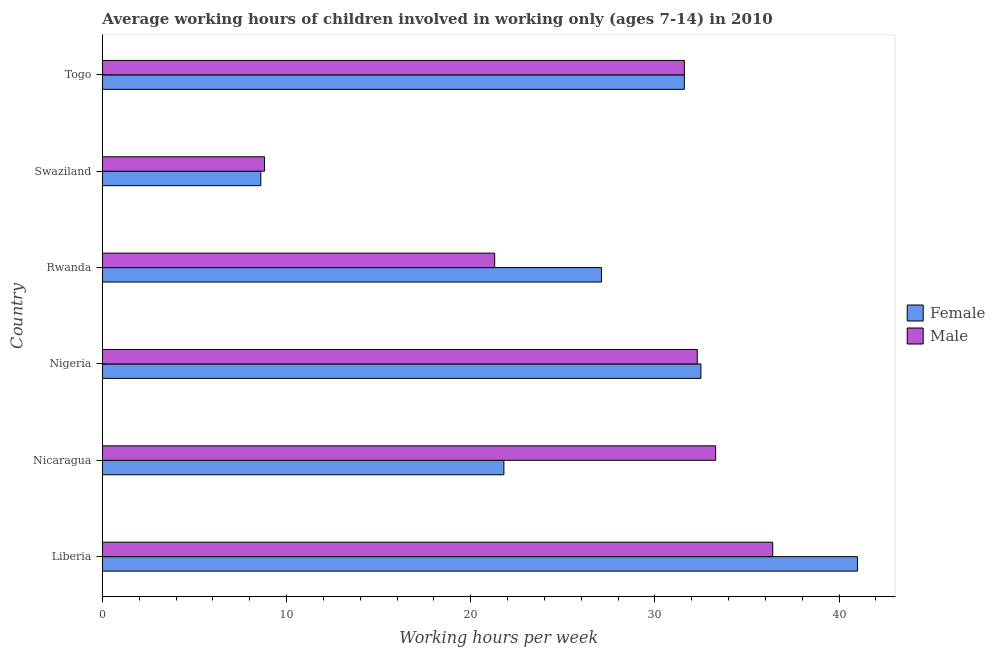Are the number of bars on each tick of the Y-axis equal?
Provide a short and direct response. Yes. What is the label of the 5th group of bars from the top?
Provide a succinct answer. Nicaragua. In how many cases, is the number of bars for a given country not equal to the number of legend labels?
Your answer should be very brief. 0. What is the average working hour of male children in Togo?
Offer a terse response. 31.6. Across all countries, what is the maximum average working hour of male children?
Your response must be concise. 36.4. In which country was the average working hour of female children maximum?
Make the answer very short. Liberia. In which country was the average working hour of female children minimum?
Make the answer very short. Swaziland. What is the total average working hour of male children in the graph?
Ensure brevity in your answer.  163.7. What is the difference between the average working hour of female children in Liberia and that in Nicaragua?
Make the answer very short. 19.2. What is the difference between the average working hour of male children in Togo and the average working hour of female children in Liberia?
Offer a terse response. -9.4. What is the average average working hour of male children per country?
Give a very brief answer. 27.28. What is the difference between the average working hour of male children and average working hour of female children in Nigeria?
Your answer should be compact. -0.2. In how many countries, is the average working hour of female children greater than 36 hours?
Offer a very short reply. 1. What is the ratio of the average working hour of female children in Nicaragua to that in Togo?
Keep it short and to the point. 0.69. Is the average working hour of male children in Liberia less than that in Rwanda?
Provide a short and direct response. No. What is the difference between the highest and the second highest average working hour of female children?
Provide a succinct answer. 8.5. What is the difference between the highest and the lowest average working hour of male children?
Offer a very short reply. 27.6. In how many countries, is the average working hour of male children greater than the average average working hour of male children taken over all countries?
Your answer should be compact. 4. What does the 1st bar from the top in Liberia represents?
Give a very brief answer. Male. What does the 2nd bar from the bottom in Nigeria represents?
Offer a terse response. Male. Are all the bars in the graph horizontal?
Offer a terse response. Yes. How many countries are there in the graph?
Give a very brief answer. 6. How many legend labels are there?
Your answer should be compact. 2. What is the title of the graph?
Offer a terse response. Average working hours of children involved in working only (ages 7-14) in 2010. Does "Female entrants" appear as one of the legend labels in the graph?
Keep it short and to the point. No. What is the label or title of the X-axis?
Provide a short and direct response. Working hours per week. What is the label or title of the Y-axis?
Provide a succinct answer. Country. What is the Working hours per week of Female in Liberia?
Provide a succinct answer. 41. What is the Working hours per week of Male in Liberia?
Your answer should be very brief. 36.4. What is the Working hours per week in Female in Nicaragua?
Offer a very short reply. 21.8. What is the Working hours per week of Male in Nicaragua?
Offer a terse response. 33.3. What is the Working hours per week of Female in Nigeria?
Provide a short and direct response. 32.5. What is the Working hours per week in Male in Nigeria?
Your answer should be very brief. 32.3. What is the Working hours per week in Female in Rwanda?
Offer a very short reply. 27.1. What is the Working hours per week in Male in Rwanda?
Provide a short and direct response. 21.3. What is the Working hours per week of Male in Swaziland?
Keep it short and to the point. 8.8. What is the Working hours per week of Female in Togo?
Your answer should be compact. 31.6. What is the Working hours per week of Male in Togo?
Offer a very short reply. 31.6. Across all countries, what is the maximum Working hours per week of Female?
Your answer should be very brief. 41. Across all countries, what is the maximum Working hours per week in Male?
Make the answer very short. 36.4. Across all countries, what is the minimum Working hours per week in Female?
Offer a very short reply. 8.6. Across all countries, what is the minimum Working hours per week in Male?
Give a very brief answer. 8.8. What is the total Working hours per week in Female in the graph?
Provide a short and direct response. 162.6. What is the total Working hours per week in Male in the graph?
Your answer should be compact. 163.7. What is the difference between the Working hours per week of Female in Liberia and that in Nicaragua?
Give a very brief answer. 19.2. What is the difference between the Working hours per week in Male in Liberia and that in Nicaragua?
Keep it short and to the point. 3.1. What is the difference between the Working hours per week in Female in Liberia and that in Rwanda?
Ensure brevity in your answer.  13.9. What is the difference between the Working hours per week in Female in Liberia and that in Swaziland?
Provide a succinct answer. 32.4. What is the difference between the Working hours per week in Male in Liberia and that in Swaziland?
Offer a very short reply. 27.6. What is the difference between the Working hours per week of Male in Liberia and that in Togo?
Make the answer very short. 4.8. What is the difference between the Working hours per week in Female in Nicaragua and that in Nigeria?
Offer a terse response. -10.7. What is the difference between the Working hours per week in Male in Nicaragua and that in Nigeria?
Offer a very short reply. 1. What is the difference between the Working hours per week of Female in Nicaragua and that in Rwanda?
Give a very brief answer. -5.3. What is the difference between the Working hours per week in Male in Nicaragua and that in Rwanda?
Provide a short and direct response. 12. What is the difference between the Working hours per week in Male in Nicaragua and that in Swaziland?
Offer a terse response. 24.5. What is the difference between the Working hours per week of Female in Nicaragua and that in Togo?
Your answer should be very brief. -9.8. What is the difference between the Working hours per week in Female in Nigeria and that in Rwanda?
Ensure brevity in your answer.  5.4. What is the difference between the Working hours per week of Male in Nigeria and that in Rwanda?
Your answer should be very brief. 11. What is the difference between the Working hours per week in Female in Nigeria and that in Swaziland?
Your response must be concise. 23.9. What is the difference between the Working hours per week in Female in Rwanda and that in Togo?
Keep it short and to the point. -4.5. What is the difference between the Working hours per week in Female in Swaziland and that in Togo?
Make the answer very short. -23. What is the difference between the Working hours per week of Male in Swaziland and that in Togo?
Your response must be concise. -22.8. What is the difference between the Working hours per week of Female in Liberia and the Working hours per week of Male in Rwanda?
Your answer should be compact. 19.7. What is the difference between the Working hours per week in Female in Liberia and the Working hours per week in Male in Swaziland?
Your answer should be compact. 32.2. What is the difference between the Working hours per week of Female in Nicaragua and the Working hours per week of Male in Togo?
Provide a short and direct response. -9.8. What is the difference between the Working hours per week of Female in Nigeria and the Working hours per week of Male in Rwanda?
Your answer should be very brief. 11.2. What is the difference between the Working hours per week of Female in Nigeria and the Working hours per week of Male in Swaziland?
Offer a terse response. 23.7. What is the difference between the Working hours per week in Female in Nigeria and the Working hours per week in Male in Togo?
Keep it short and to the point. 0.9. What is the difference between the Working hours per week of Female in Rwanda and the Working hours per week of Male in Swaziland?
Your answer should be very brief. 18.3. What is the difference between the Working hours per week of Female in Rwanda and the Working hours per week of Male in Togo?
Make the answer very short. -4.5. What is the average Working hours per week in Female per country?
Ensure brevity in your answer.  27.1. What is the average Working hours per week in Male per country?
Offer a terse response. 27.28. What is the difference between the Working hours per week in Female and Working hours per week in Male in Liberia?
Your answer should be very brief. 4.6. What is the difference between the Working hours per week of Female and Working hours per week of Male in Nicaragua?
Make the answer very short. -11.5. What is the difference between the Working hours per week of Female and Working hours per week of Male in Rwanda?
Offer a very short reply. 5.8. What is the difference between the Working hours per week of Female and Working hours per week of Male in Swaziland?
Offer a very short reply. -0.2. What is the ratio of the Working hours per week of Female in Liberia to that in Nicaragua?
Give a very brief answer. 1.88. What is the ratio of the Working hours per week in Male in Liberia to that in Nicaragua?
Ensure brevity in your answer.  1.09. What is the ratio of the Working hours per week in Female in Liberia to that in Nigeria?
Keep it short and to the point. 1.26. What is the ratio of the Working hours per week in Male in Liberia to that in Nigeria?
Give a very brief answer. 1.13. What is the ratio of the Working hours per week of Female in Liberia to that in Rwanda?
Provide a short and direct response. 1.51. What is the ratio of the Working hours per week in Male in Liberia to that in Rwanda?
Provide a succinct answer. 1.71. What is the ratio of the Working hours per week of Female in Liberia to that in Swaziland?
Keep it short and to the point. 4.77. What is the ratio of the Working hours per week of Male in Liberia to that in Swaziland?
Your response must be concise. 4.14. What is the ratio of the Working hours per week in Female in Liberia to that in Togo?
Offer a very short reply. 1.3. What is the ratio of the Working hours per week of Male in Liberia to that in Togo?
Your answer should be compact. 1.15. What is the ratio of the Working hours per week in Female in Nicaragua to that in Nigeria?
Ensure brevity in your answer.  0.67. What is the ratio of the Working hours per week of Male in Nicaragua to that in Nigeria?
Make the answer very short. 1.03. What is the ratio of the Working hours per week in Female in Nicaragua to that in Rwanda?
Provide a succinct answer. 0.8. What is the ratio of the Working hours per week of Male in Nicaragua to that in Rwanda?
Give a very brief answer. 1.56. What is the ratio of the Working hours per week in Female in Nicaragua to that in Swaziland?
Your response must be concise. 2.53. What is the ratio of the Working hours per week of Male in Nicaragua to that in Swaziland?
Your answer should be very brief. 3.78. What is the ratio of the Working hours per week in Female in Nicaragua to that in Togo?
Make the answer very short. 0.69. What is the ratio of the Working hours per week of Male in Nicaragua to that in Togo?
Give a very brief answer. 1.05. What is the ratio of the Working hours per week in Female in Nigeria to that in Rwanda?
Your answer should be very brief. 1.2. What is the ratio of the Working hours per week of Male in Nigeria to that in Rwanda?
Provide a short and direct response. 1.52. What is the ratio of the Working hours per week in Female in Nigeria to that in Swaziland?
Make the answer very short. 3.78. What is the ratio of the Working hours per week in Male in Nigeria to that in Swaziland?
Provide a succinct answer. 3.67. What is the ratio of the Working hours per week in Female in Nigeria to that in Togo?
Your response must be concise. 1.03. What is the ratio of the Working hours per week of Male in Nigeria to that in Togo?
Provide a short and direct response. 1.02. What is the ratio of the Working hours per week in Female in Rwanda to that in Swaziland?
Make the answer very short. 3.15. What is the ratio of the Working hours per week of Male in Rwanda to that in Swaziland?
Make the answer very short. 2.42. What is the ratio of the Working hours per week in Female in Rwanda to that in Togo?
Provide a short and direct response. 0.86. What is the ratio of the Working hours per week of Male in Rwanda to that in Togo?
Make the answer very short. 0.67. What is the ratio of the Working hours per week of Female in Swaziland to that in Togo?
Your answer should be very brief. 0.27. What is the ratio of the Working hours per week in Male in Swaziland to that in Togo?
Your answer should be compact. 0.28. What is the difference between the highest and the second highest Working hours per week of Female?
Provide a succinct answer. 8.5. What is the difference between the highest and the lowest Working hours per week in Female?
Provide a succinct answer. 32.4. What is the difference between the highest and the lowest Working hours per week in Male?
Your answer should be compact. 27.6. 